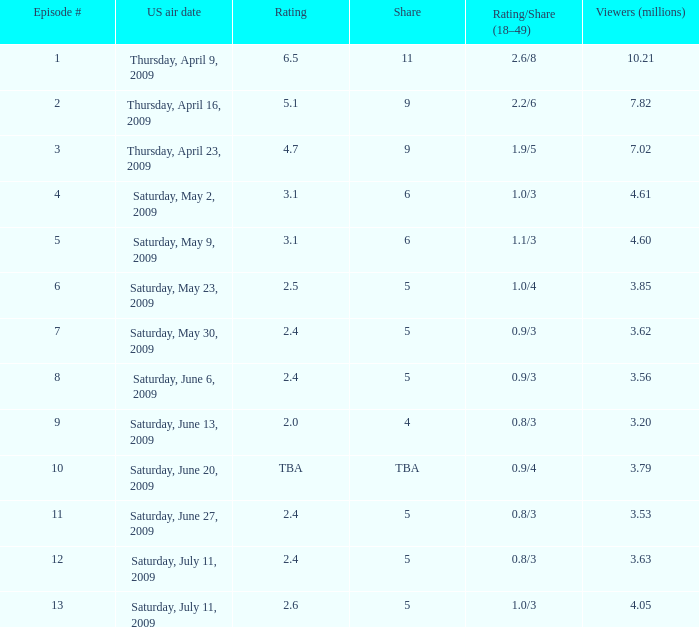For episode 13, what are the rating and share values? 1.0/3. 